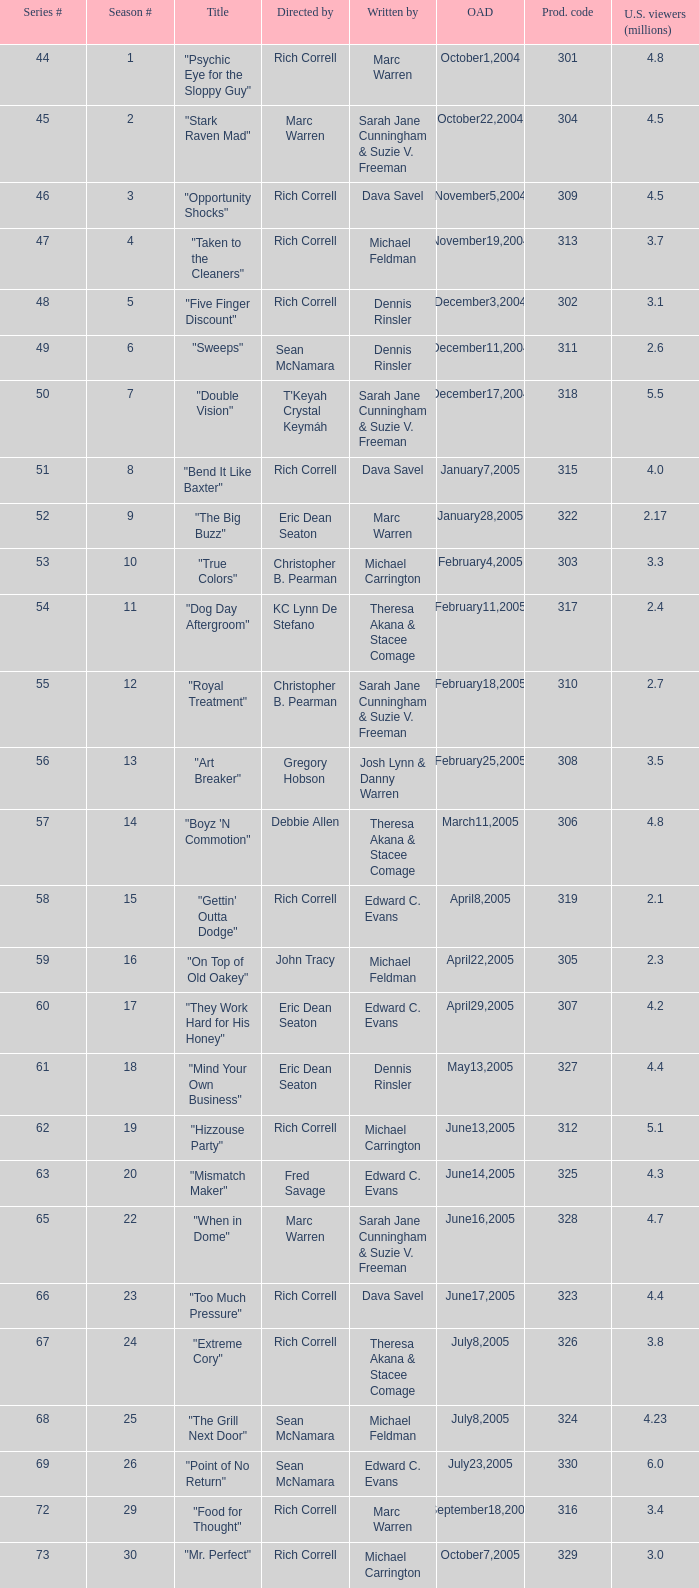What was the production number of the episode directed by rondell sheridan? 332.0. 